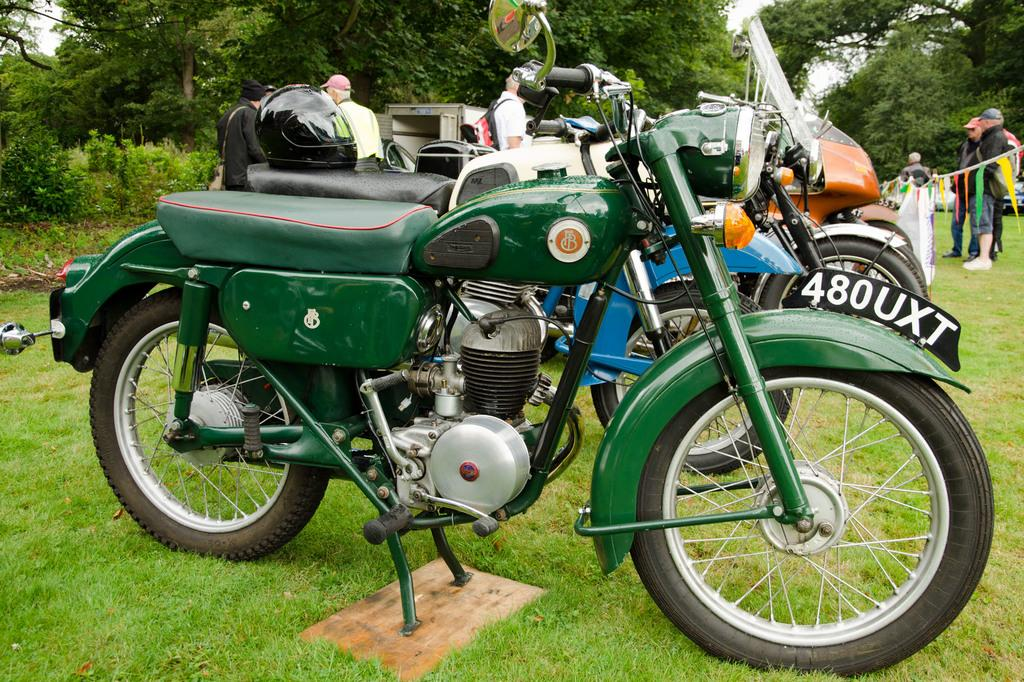Who or what is present in the image? There are people and vehicles in the image. Can you describe the location of the vehicles? The vehicles are on the grass in the image. What safety equipment is visible on the motorcycle? There is a helmet on the motorcycle. What can be seen in the background of the image? There are trees in the background of the image. What type of wave can be seen crashing on the shore in the image? There is no wave or shore present in the image; it features people and vehicles on grass with trees in the background. 